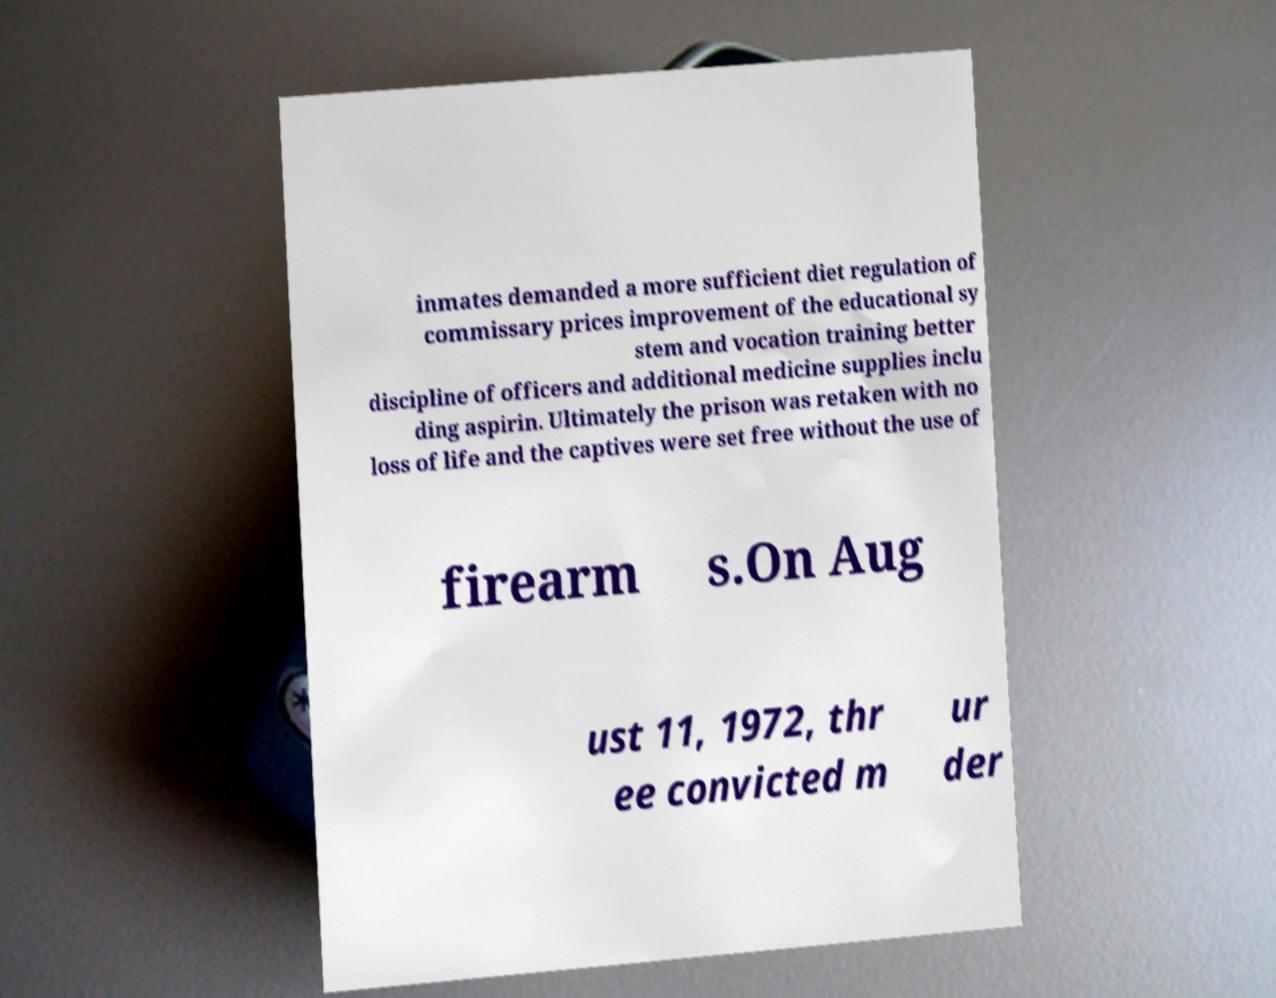There's text embedded in this image that I need extracted. Can you transcribe it verbatim? inmates demanded a more sufficient diet regulation of commissary prices improvement of the educational sy stem and vocation training better discipline of officers and additional medicine supplies inclu ding aspirin. Ultimately the prison was retaken with no loss of life and the captives were set free without the use of firearm s.On Aug ust 11, 1972, thr ee convicted m ur der 